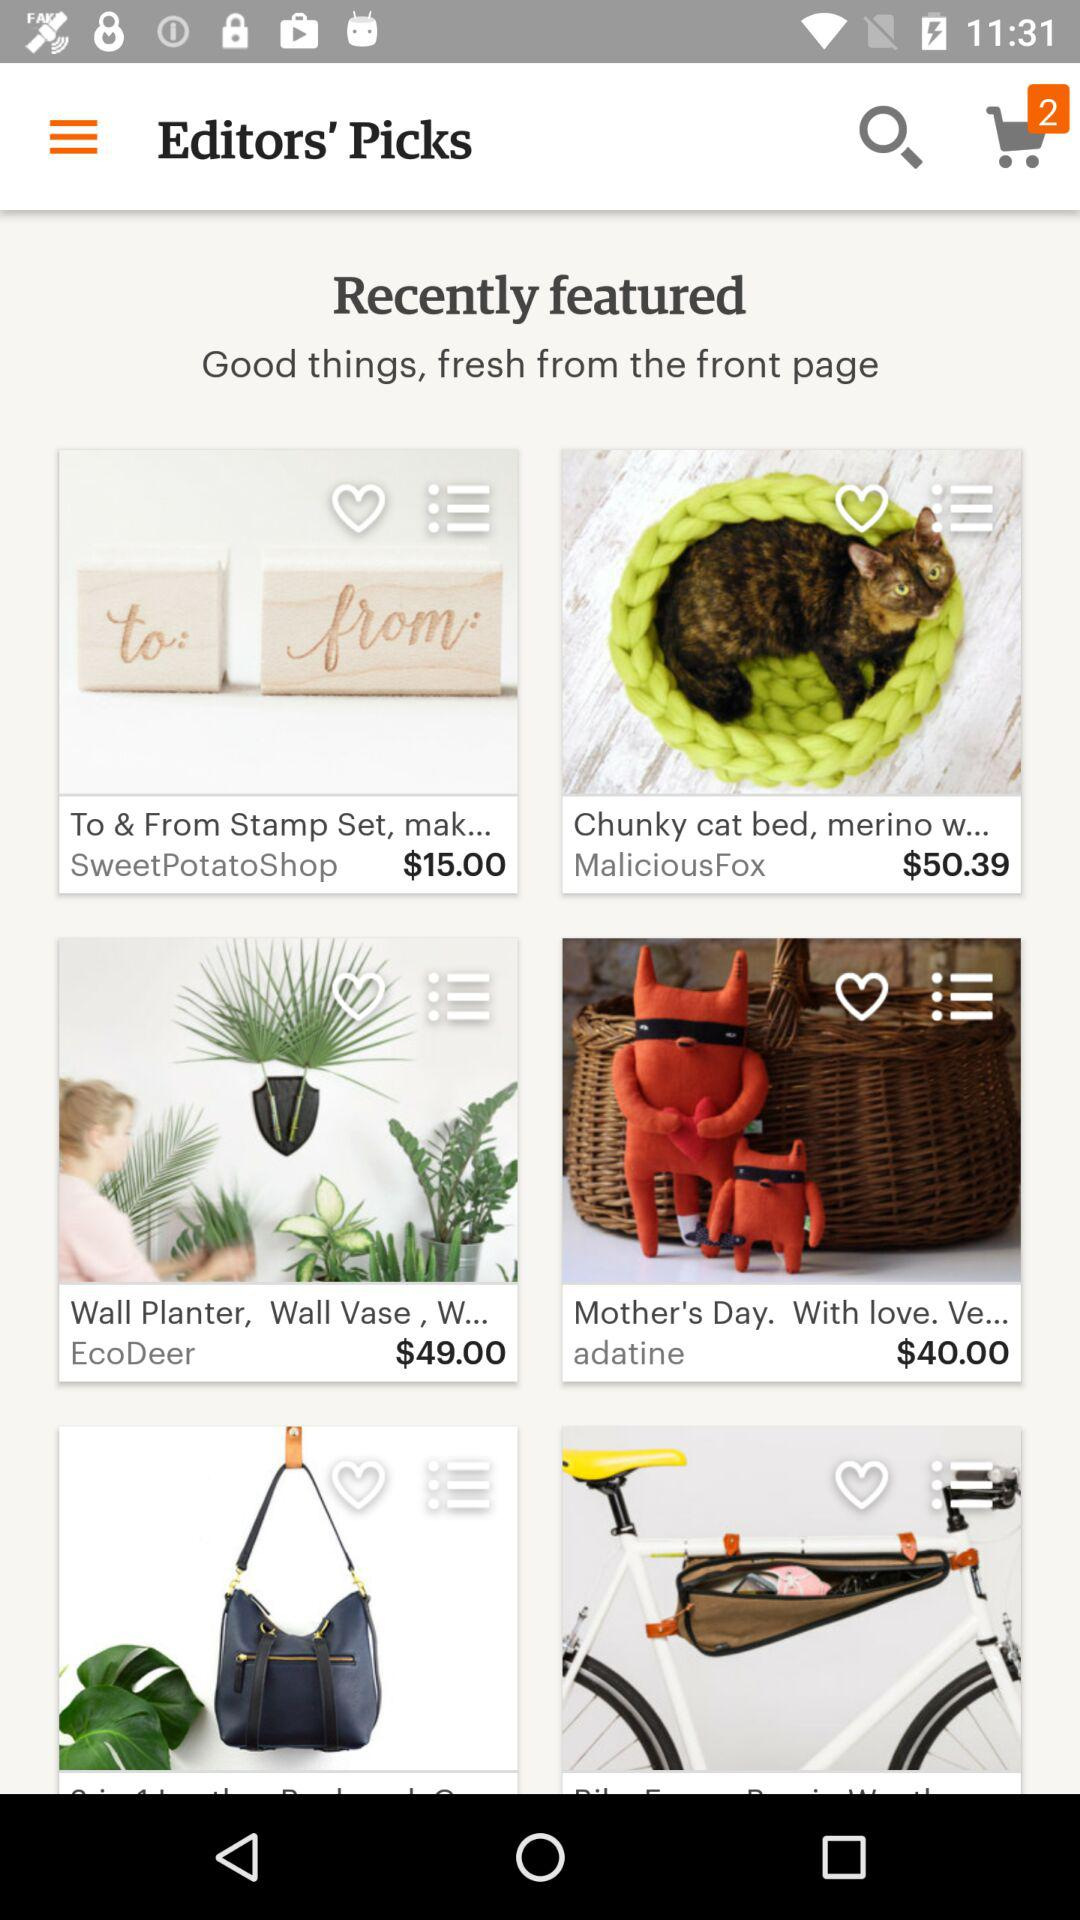What is the price of the "Chunky cat bed"? The price is $50.39. 